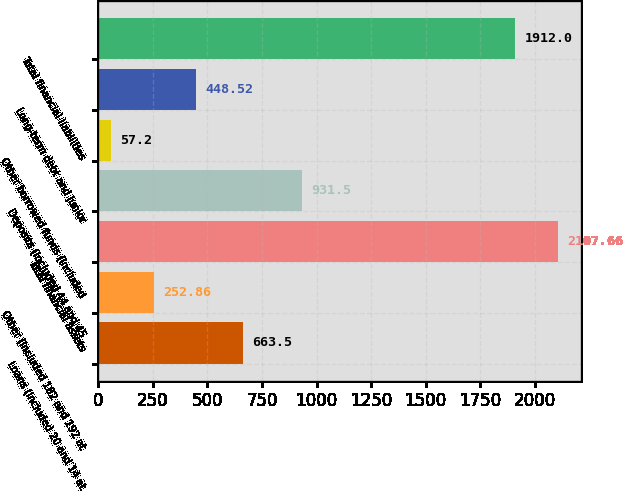Convert chart. <chart><loc_0><loc_0><loc_500><loc_500><bar_chart><fcel>Loans (included 20 and 14 at<fcel>Other (included 182 and 192 at<fcel>Total financial assets<fcel>Deposits (included 44 and 45<fcel>Other borrowed funds (included<fcel>Long-term debt and junior<fcel>Total financial liabilities<nl><fcel>663.5<fcel>252.86<fcel>2107.66<fcel>931.5<fcel>57.2<fcel>448.52<fcel>1912<nl></chart> 